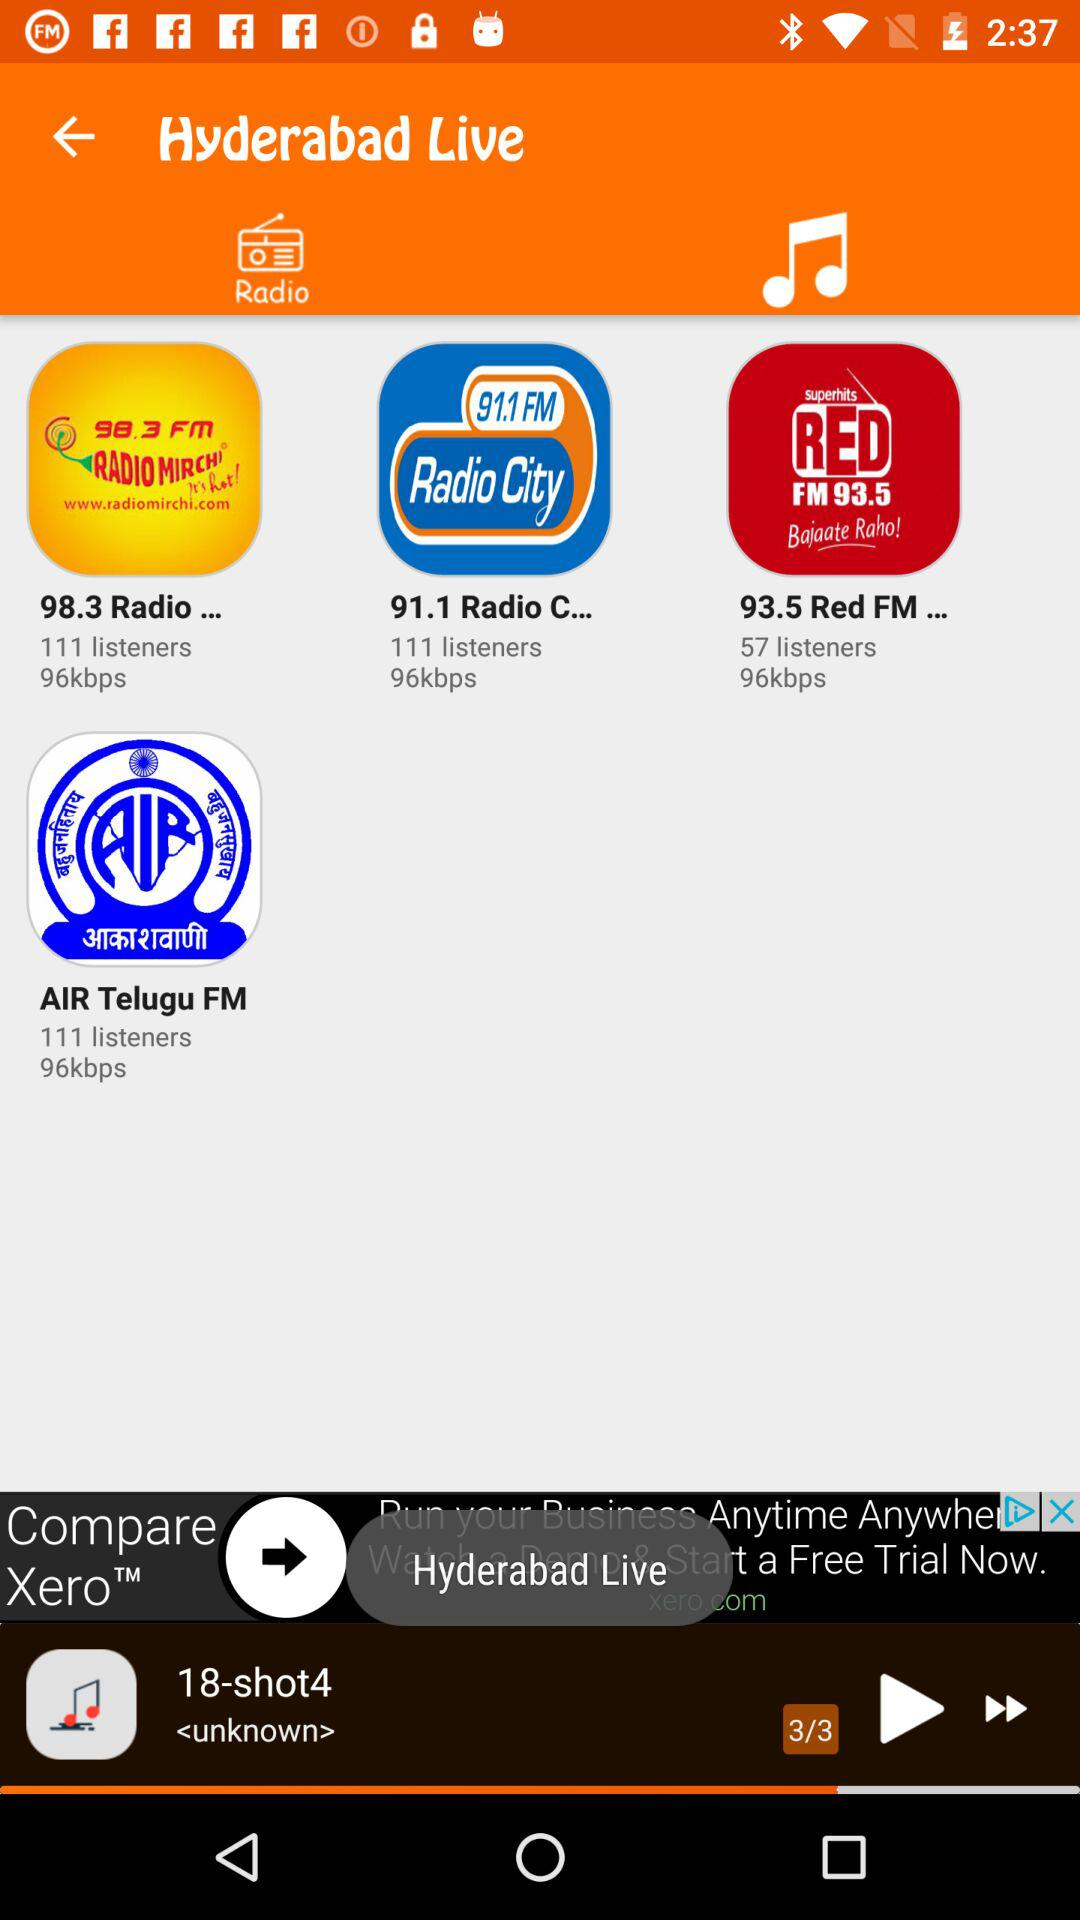Which song is selected to play? The song is "18-shot4". 